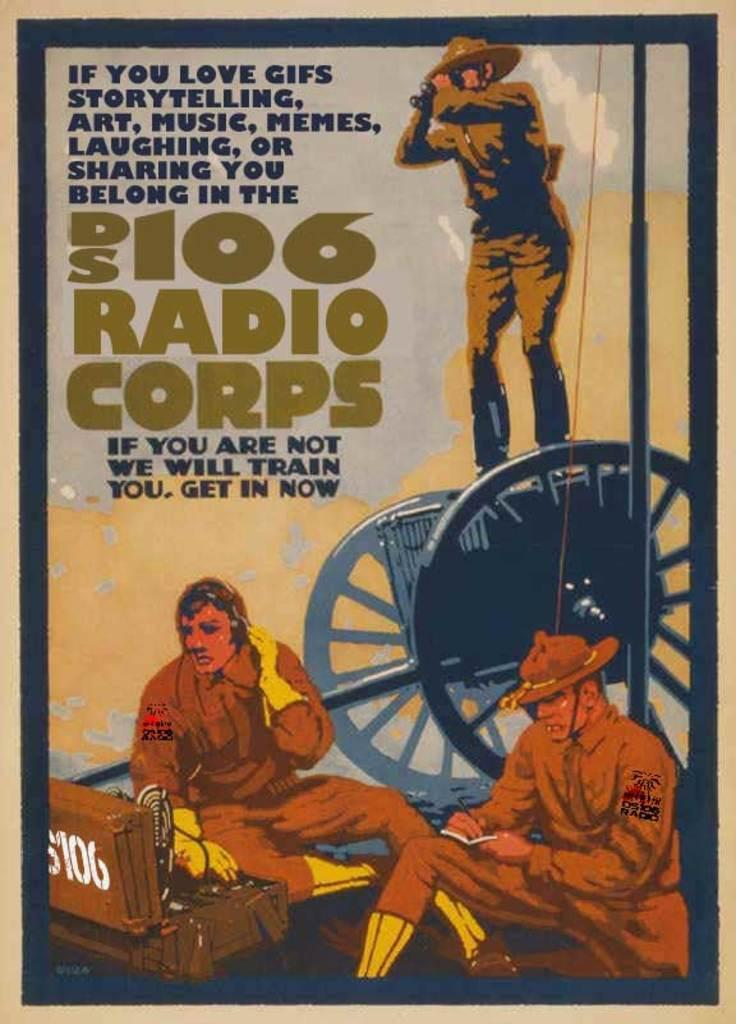<image>
Share a concise interpretation of the image provided. An older looking advertisement about DS106 Radio Corps. 